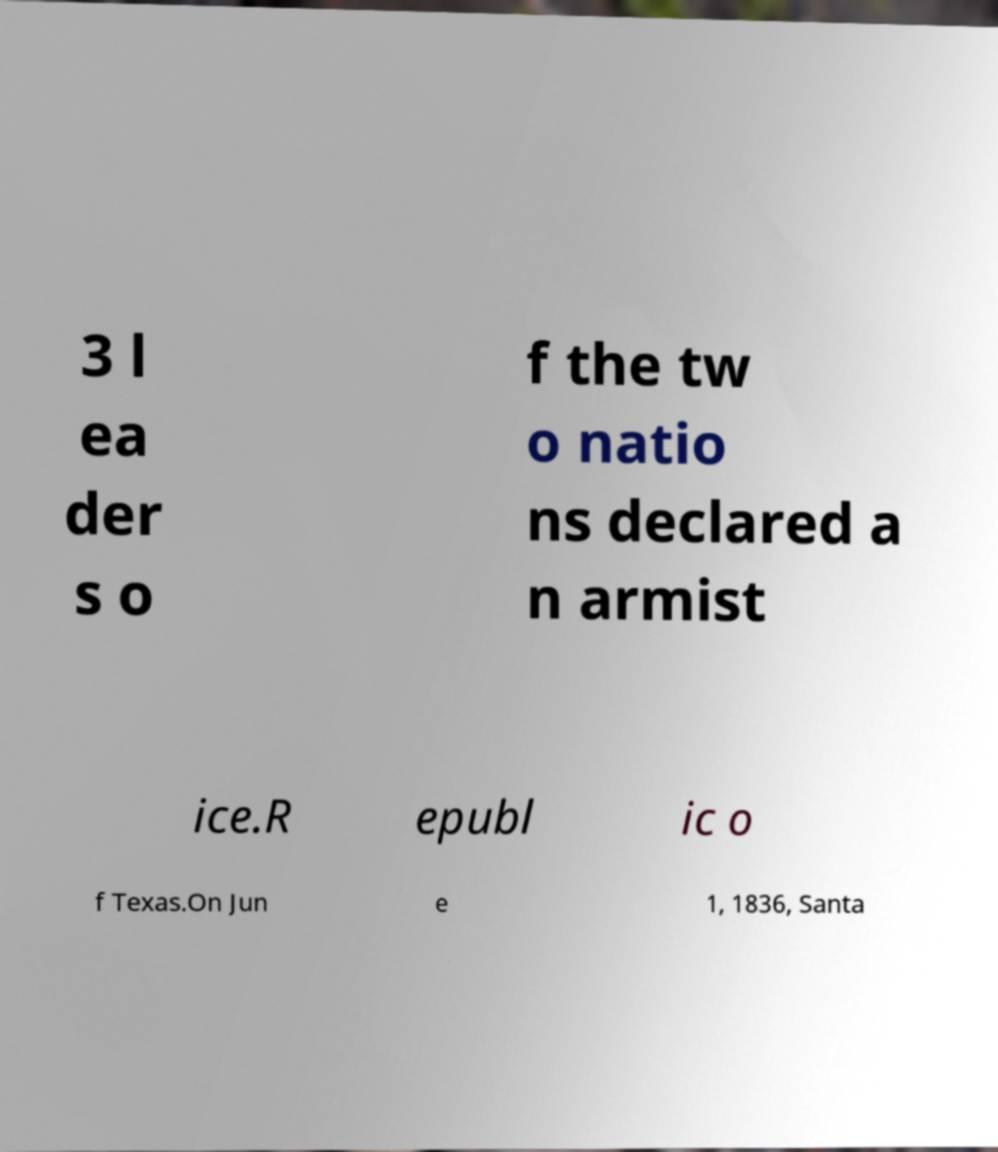Please read and relay the text visible in this image. What does it say? 3 l ea der s o f the tw o natio ns declared a n armist ice.R epubl ic o f Texas.On Jun e 1, 1836, Santa 